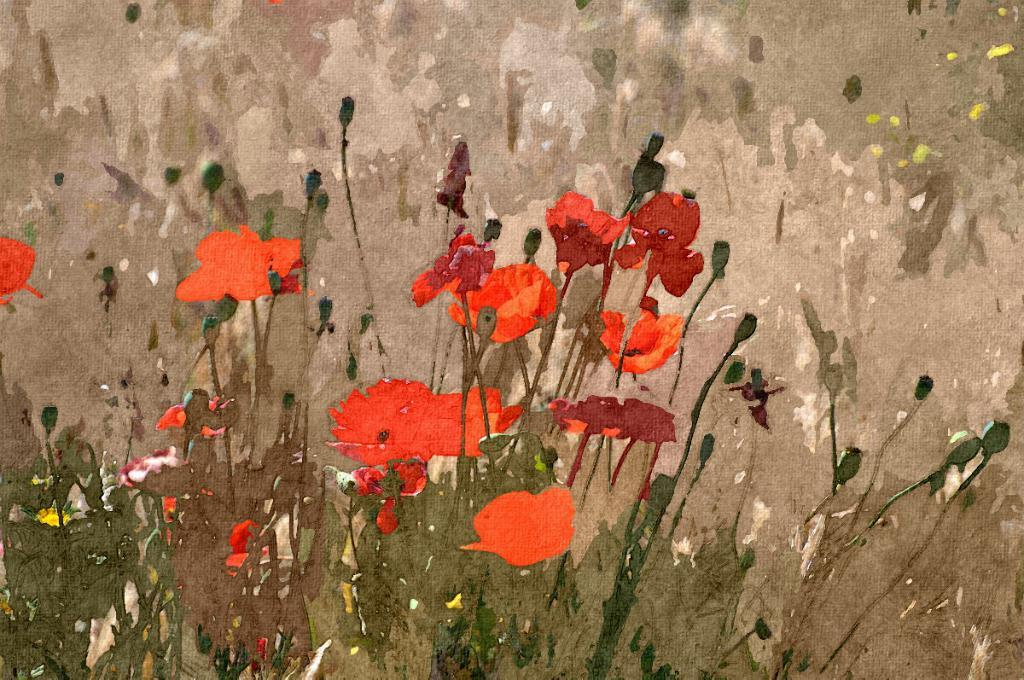What type of living organisms are depicted in the image? There are flowers on plants in the image. What medium was used to create the image? The image is painted. What type of wrench is being used to adjust the temperature in the image? There is no wrench or temperature adjustment present in the image; it features flowers on plants and is painted. 